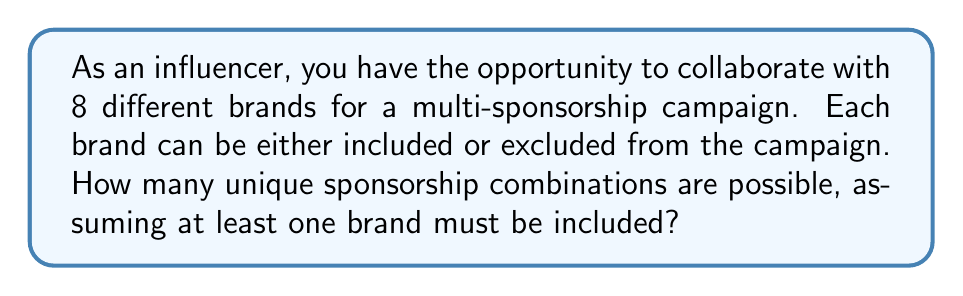Teach me how to tackle this problem. Let's approach this step-by-step:

1) First, we need to understand that for each brand, we have two choices: include it or exclude it. This suggests we're dealing with a binary choice for each brand.

2) With 8 brands and 2 choices for each, we might initially think the total number of combinations is $2^8 = 256$.

3) However, the question states that at least one brand must be included. This means we need to subtract the case where all brands are excluded.

4) To calculate this, we can use the concept of complementary counting:
   - Total possible combinations: $2^8 = 256$
   - Combinations with at least one brand = All combinations - Combinations with no brands
   
5) Mathematically, this can be expressed as:
   $$ \text{Combinations with at least one brand} = 2^8 - 1 $$

6) Calculating:
   $$ 256 - 1 = 255 $$

Therefore, there are 255 unique sponsorship combinations possible.
Answer: 255 